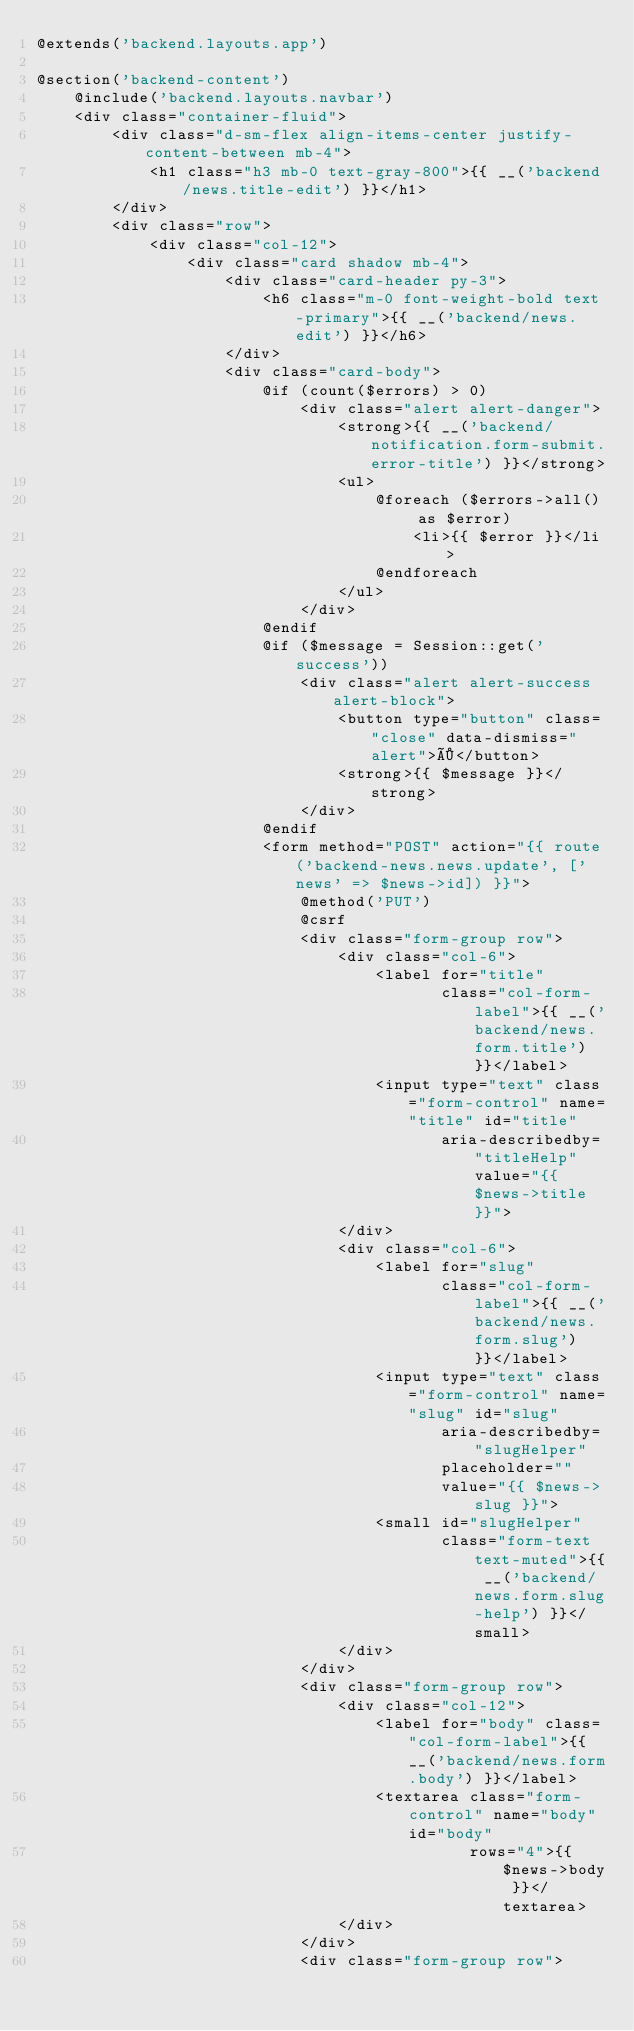<code> <loc_0><loc_0><loc_500><loc_500><_PHP_>@extends('backend.layouts.app')

@section('backend-content')
    @include('backend.layouts.navbar')
    <div class="container-fluid">
        <div class="d-sm-flex align-items-center justify-content-between mb-4">
            <h1 class="h3 mb-0 text-gray-800">{{ __('backend/news.title-edit') }}</h1>
        </div>
        <div class="row">
            <div class="col-12">
                <div class="card shadow mb-4">
                    <div class="card-header py-3">
                        <h6 class="m-0 font-weight-bold text-primary">{{ __('backend/news.edit') }}</h6>
                    </div>
                    <div class="card-body">
                        @if (count($errors) > 0)
                            <div class="alert alert-danger">
                                <strong>{{ __('backend/notification.form-submit.error-title') }}</strong>
                                <ul>
                                    @foreach ($errors->all() as $error)
                                        <li>{{ $error }}</li>
                                    @endforeach
                                </ul>
                            </div>
                        @endif
                        @if ($message = Session::get('success'))
                            <div class="alert alert-success alert-block">
                                <button type="button" class="close" data-dismiss="alert">×</button>
                                <strong>{{ $message }}</strong>
                            </div>
                        @endif
                        <form method="POST" action="{{ route('backend-news.news.update', ['news' => $news->id]) }}">
                            @method('PUT')
                            @csrf
                            <div class="form-group row">
                                <div class="col-6">
                                    <label for="title"
                                           class="col-form-label">{{ __('backend/news.form.title') }}</label>
                                    <input type="text" class="form-control" name="title" id="title"
                                           aria-describedby="titleHelp" value="{{ $news->title }}">
                                </div>
                                <div class="col-6">
                                    <label for="slug"
                                           class="col-form-label">{{ __('backend/news.form.slug') }}</label>
                                    <input type="text" class="form-control" name="slug" id="slug"
                                           aria-describedby="slugHelper"
                                           placeholder=""
                                           value="{{ $news->slug }}">
                                    <small id="slugHelper"
                                           class="form-text text-muted">{{ __('backend/news.form.slug-help') }}</small>
                                </div>
                            </div>
                            <div class="form-group row">
                                <div class="col-12">
                                    <label for="body" class="col-form-label">{{ __('backend/news.form.body') }}</label>
                                    <textarea class="form-control" name="body" id="body"
                                              rows="4">{{ $news->body }}</textarea>
                                </div>
                            </div>
                            <div class="form-group row"></code> 